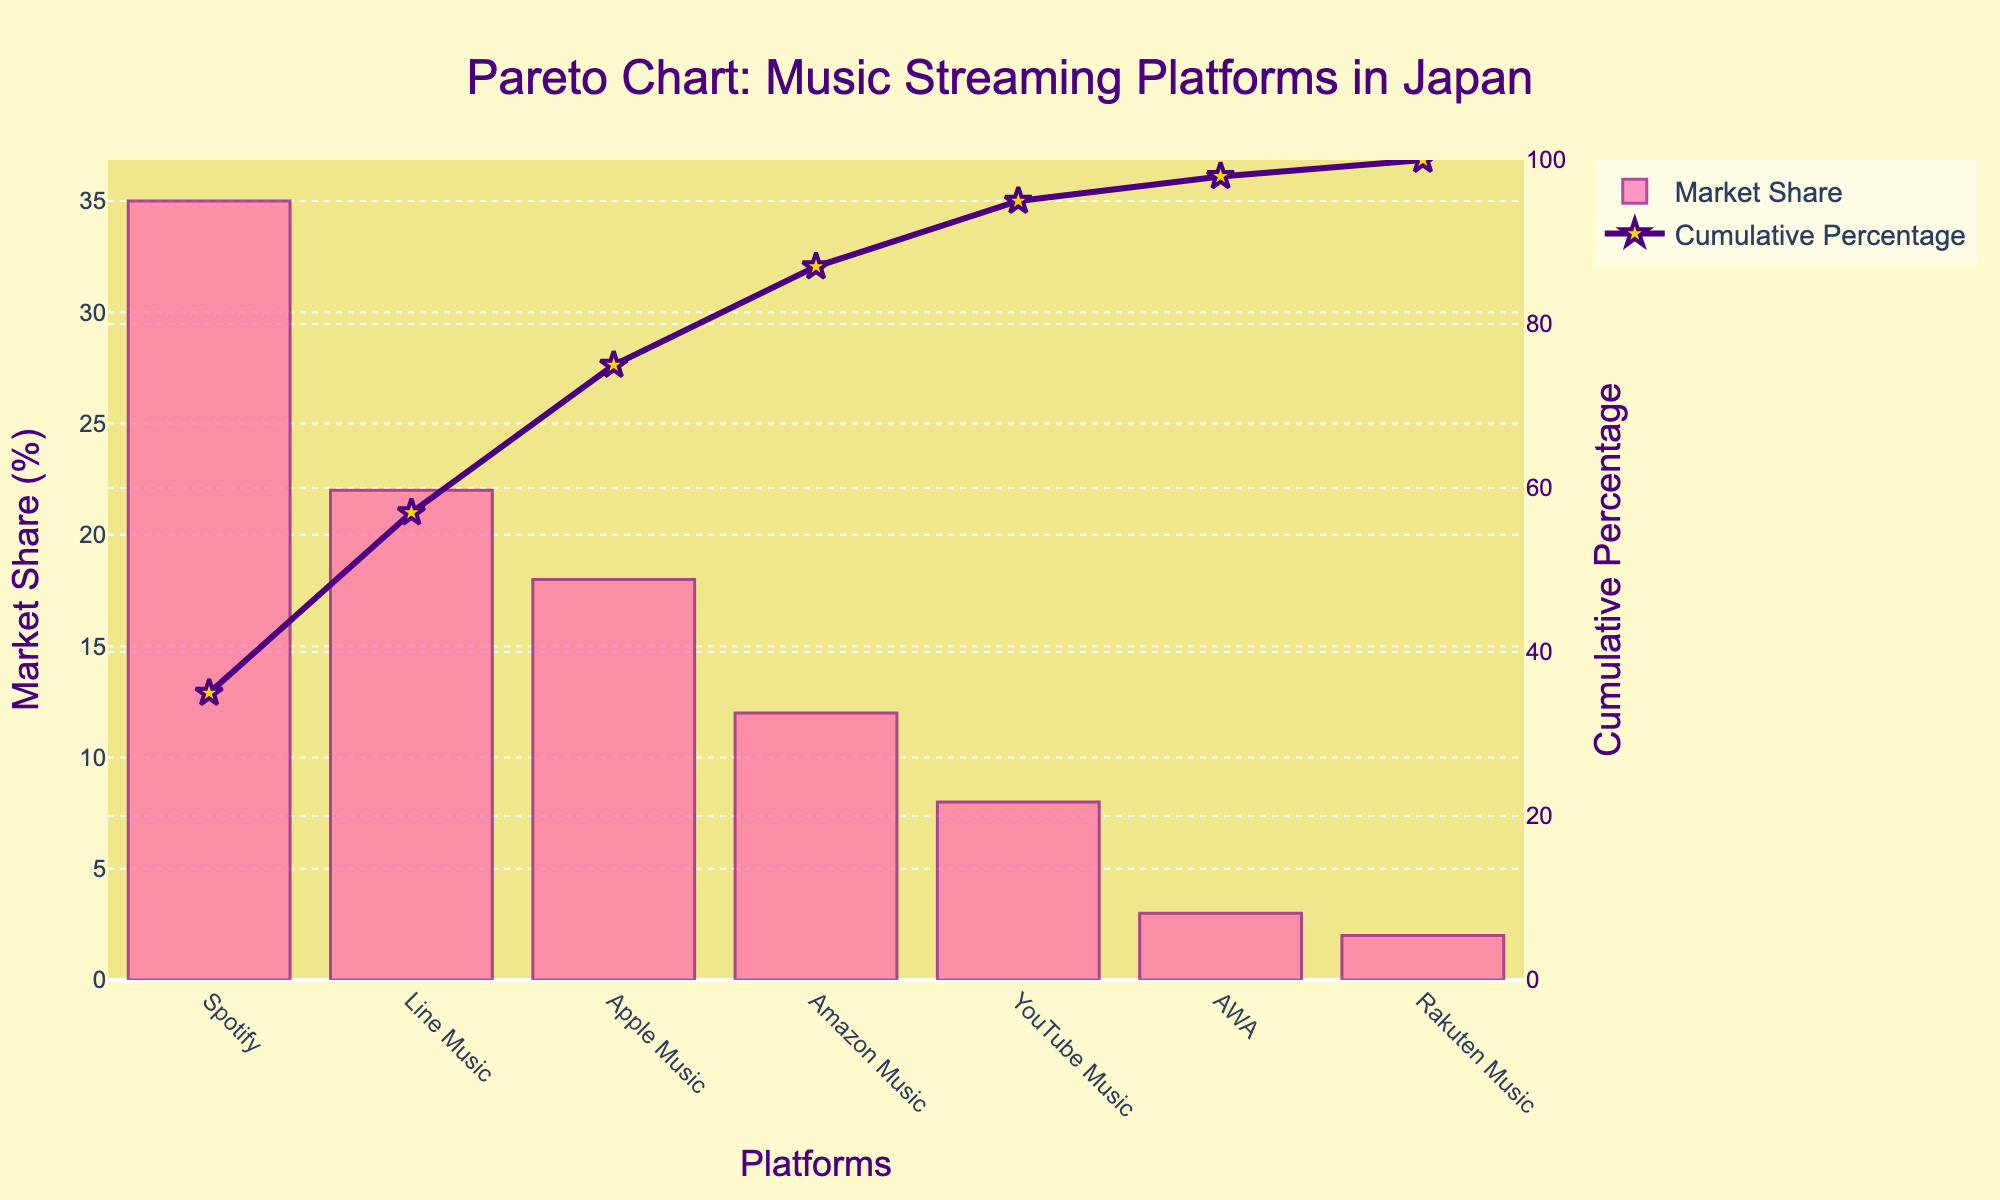What's the title of the Pareto chart? The title is located at the top center of the chart in a larger font size relative to the rest of the text, making it easily identifiable.
Answer: "Pareto Chart: Music Streaming Platforms in Japan" Which streaming platform has the highest market share among Japanese listeners? By looking at the height of the bars, the platform with the tallest bar represents the highest market share. The tallest bar is labeled "Spotify."
Answer: Spotify What is the cumulative percentage for Amazon Music? Follow the line graph corresponding to Amazon Music, which should be located above the Amazon Music bar. The y-axis on the right indicates the cumulative percentage.
Answer: 87% How many platforms have a market share greater than or equal to 20%? Identify the platforms by looking at the heights of the bars relative to the y-axis on the left. Only Spotify and Line Music have bars extending to or beyond the 20% mark.
Answer: 2 Which platform just surpasses the 80% cumulative percentage mark? Locate the point on the cumulative percentage line that slightly exceeds 80% on the y-axis on the right. The corresponding x-axis label is the platform exceeding the 80% mark.
Answer: Amazon Music What is the combined market share of YouTube Music and AWA? Locate the bar heights for YouTube Music and AWA, which are 8% and 3% respectively. Adding these two market share values gives 8% + 3% = 11%.
Answer: 11% How does the market share of Line Music compare to that of Apple Music? Compare the heights of the bars for Line Music and Apple Music. Line Music has a bar of 22%, and Apple Music has a bar at 18%.
Answer: Line Music Which platform has the least market share and what is its value? The shortest bar in the chart represents the platform with the least market share. This bar is labeled "Rakuten Music" with a market share of 2%.
Answer: Rakuten Music, 2% What is the difference in market share between Spotify and Apple Music? Subtract Apple Music's market share from Spotify's market share. Spotify has 35% and Apple Music has 18%, so the difference is 35% - 18% = 17%.
Answer: 17% What is the cumulative percentage of the top 3 platforms combined? Sum the market shares of the top 3 platforms: Spotify (35%), Line Music (22%), and Apple Music (18%). The cumulative percentage is shown for Apple Music, which comes up to 75%.
Answer: 75% 